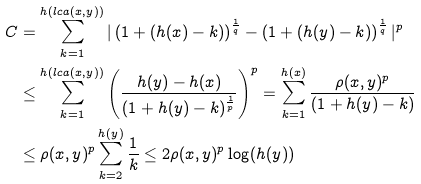Convert formula to latex. <formula><loc_0><loc_0><loc_500><loc_500>C & = \sum _ { k = 1 } ^ { h ( l c a ( x , y ) ) } | \left ( 1 + ( h ( x ) - k ) \right ) ^ { \frac { 1 } { q } } - \left ( 1 + ( h ( y ) - k ) \right ) ^ { \frac { 1 } { q } } | ^ { p } \\ & \leq \sum _ { k = 1 } ^ { h ( l c a ( x , y ) ) } \left ( \frac { h ( y ) - h ( x ) } { ( 1 + h ( y ) - k ) ^ { \frac { 1 } { p } } } \right ) ^ { p } = \sum _ { k = 1 } ^ { h ( x ) } \frac { \rho ( x , y ) ^ { p } } { ( 1 + h ( y ) - k ) } \\ & \leq \rho ( x , y ) ^ { p } \sum _ { k = 2 } ^ { h ( y ) } \frac { 1 } { k } \leq 2 \rho ( x , y ) ^ { p } \log ( h ( y ) )</formula> 